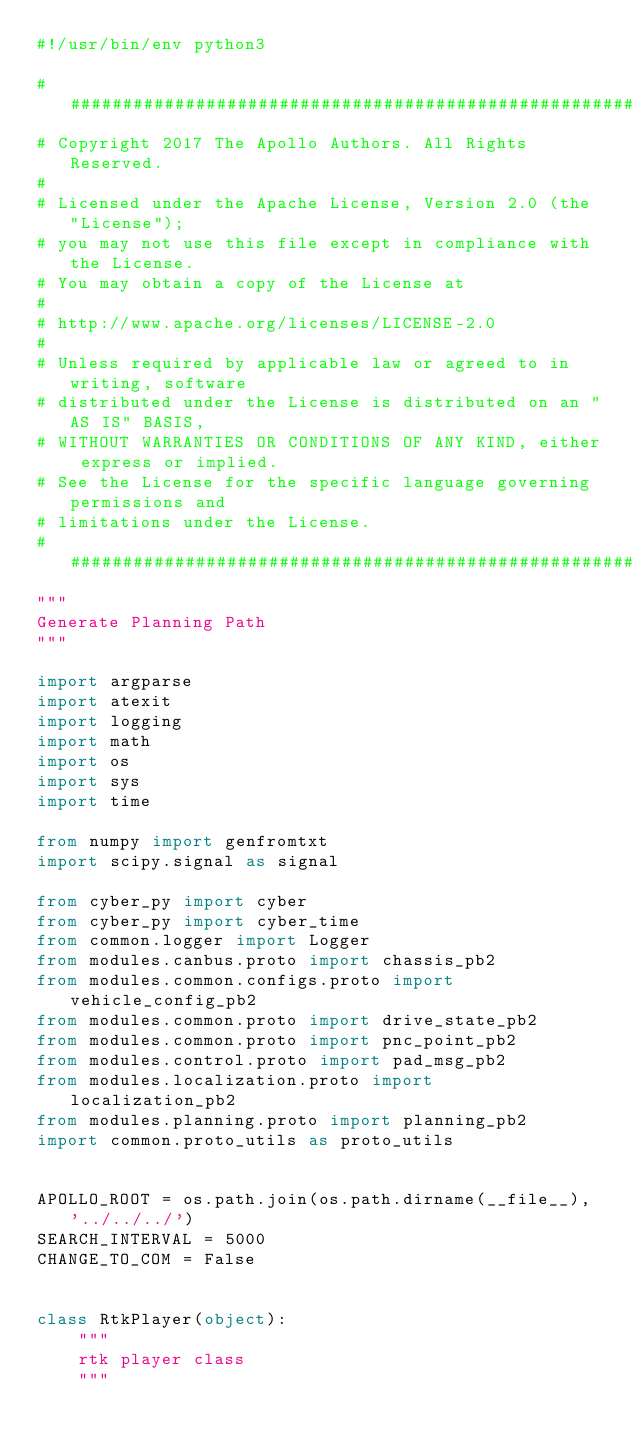<code> <loc_0><loc_0><loc_500><loc_500><_Python_>#!/usr/bin/env python3

###############################################################################
# Copyright 2017 The Apollo Authors. All Rights Reserved.
#
# Licensed under the Apache License, Version 2.0 (the "License");
# you may not use this file except in compliance with the License.
# You may obtain a copy of the License at
#
# http://www.apache.org/licenses/LICENSE-2.0
#
# Unless required by applicable law or agreed to in writing, software
# distributed under the License is distributed on an "AS IS" BASIS,
# WITHOUT WARRANTIES OR CONDITIONS OF ANY KIND, either express or implied.
# See the License for the specific language governing permissions and
# limitations under the License.
###############################################################################
"""
Generate Planning Path
"""

import argparse
import atexit
import logging
import math
import os
import sys
import time

from numpy import genfromtxt
import scipy.signal as signal

from cyber_py import cyber
from cyber_py import cyber_time
from common.logger import Logger
from modules.canbus.proto import chassis_pb2
from modules.common.configs.proto import vehicle_config_pb2
from modules.common.proto import drive_state_pb2
from modules.common.proto import pnc_point_pb2
from modules.control.proto import pad_msg_pb2
from modules.localization.proto import localization_pb2
from modules.planning.proto import planning_pb2
import common.proto_utils as proto_utils


APOLLO_ROOT = os.path.join(os.path.dirname(__file__), '../../../')
SEARCH_INTERVAL = 5000
CHANGE_TO_COM = False


class RtkPlayer(object):
    """
    rtk player class
    """
</code> 